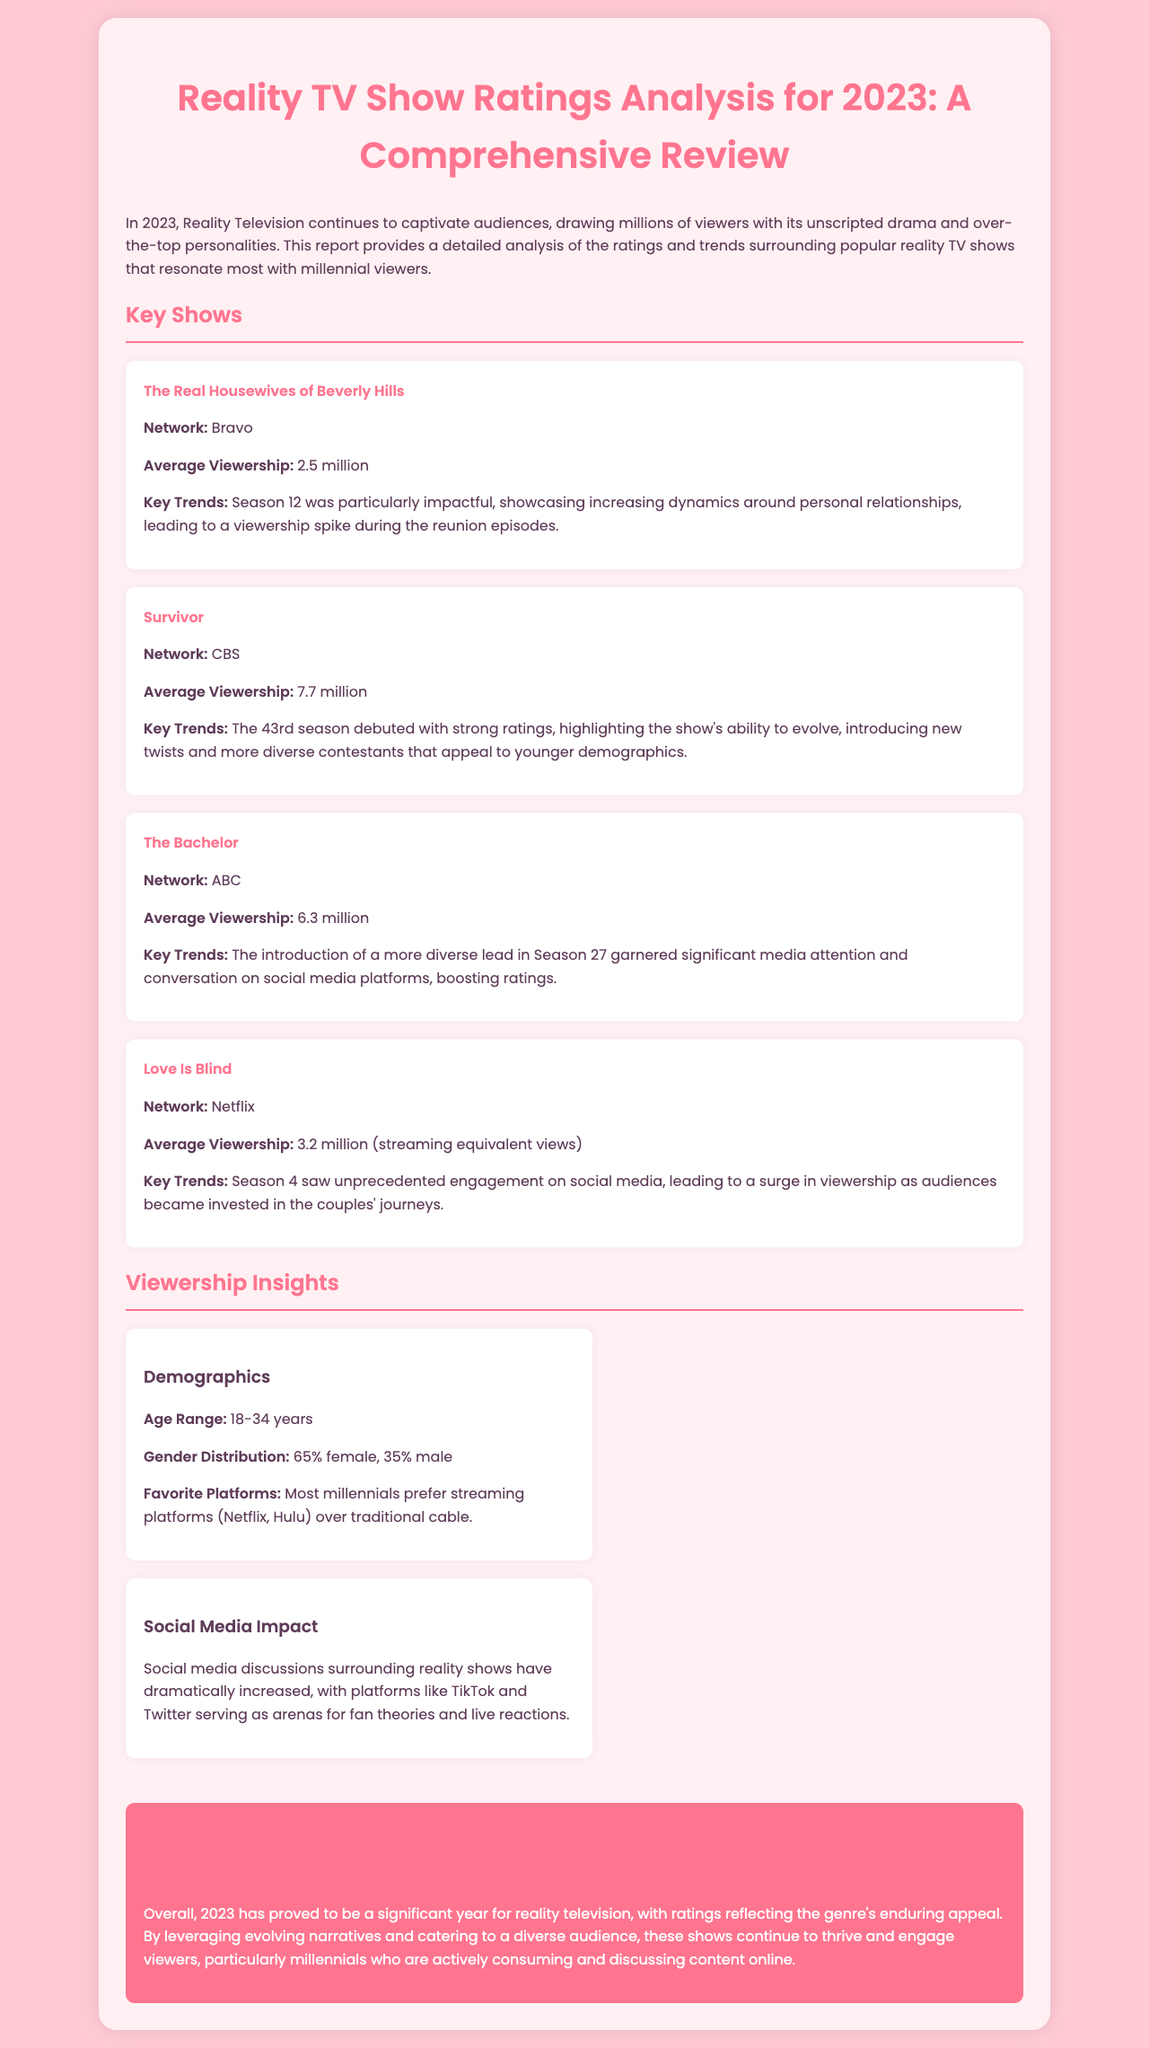What is the average viewership of The Real Housewives of Beverly Hills? The average viewership of The Real Housewives of Beverly Hills is stated in the document as 2.5 million.
Answer: 2.5 million Which network broadcasts Survivor? The document mentions that Survivor is broadcasted on CBS.
Answer: CBS What is the average viewership for Love Is Blind? The document specifies that Love Is Blind has an average viewership of 3.2 million (streaming equivalent views).
Answer: 3.2 million What was a key trend noted for The Bachelor? The document highlights that the introduction of a more diverse lead in Season 27 garnered significant media attention.
Answer: A more diverse lead in Season 27 What percentage of reality TV viewers are female? The document indicates that 65% of reality TV viewers are female.
Answer: 65% How has social media impacted reality TV discussions? The document states that social media discussions have dramatically increased, particularly on platforms like TikTok and Twitter.
Answer: Dramatically increased Which demographic shows the highest viewership for reality TV in 2023? The document notes that the age range for the highest viewership is 18-34 years.
Answer: 18-34 years What is the conclusion about reality television in 2023? The document concludes that 2023 has been significant for reality television, with ratings reflecting enduring appeal.
Answer: Significant year for reality television 